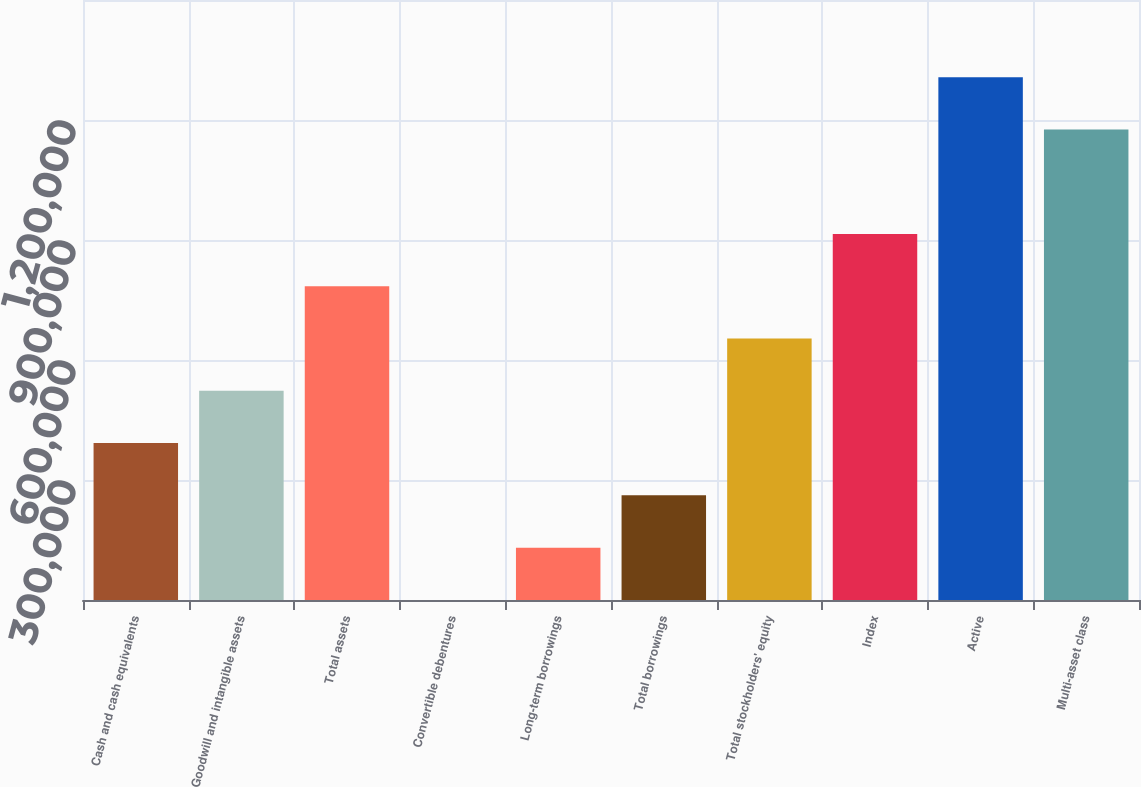<chart> <loc_0><loc_0><loc_500><loc_500><bar_chart><fcel>Cash and cash equivalents<fcel>Goodwill and intangible assets<fcel>Total assets<fcel>Convertible debentures<fcel>Long-term borrowings<fcel>Total borrowings<fcel>Total stockholders' equity<fcel>Index<fcel>Active<fcel>Multi-asset class<nl><fcel>392317<fcel>523007<fcel>784389<fcel>245<fcel>130936<fcel>261626<fcel>653698<fcel>915079<fcel>1.30715e+06<fcel>1.17646e+06<nl></chart> 